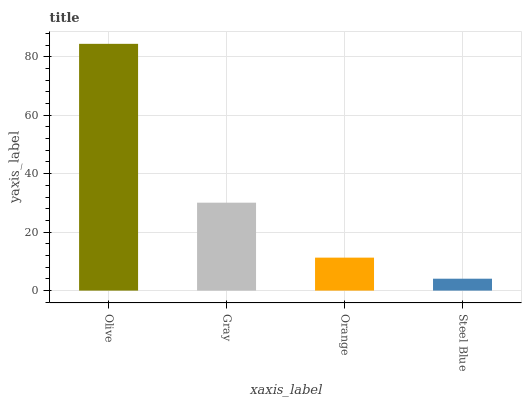Is Steel Blue the minimum?
Answer yes or no. Yes. Is Olive the maximum?
Answer yes or no. Yes. Is Gray the minimum?
Answer yes or no. No. Is Gray the maximum?
Answer yes or no. No. Is Olive greater than Gray?
Answer yes or no. Yes. Is Gray less than Olive?
Answer yes or no. Yes. Is Gray greater than Olive?
Answer yes or no. No. Is Olive less than Gray?
Answer yes or no. No. Is Gray the high median?
Answer yes or no. Yes. Is Orange the low median?
Answer yes or no. Yes. Is Steel Blue the high median?
Answer yes or no. No. Is Steel Blue the low median?
Answer yes or no. No. 